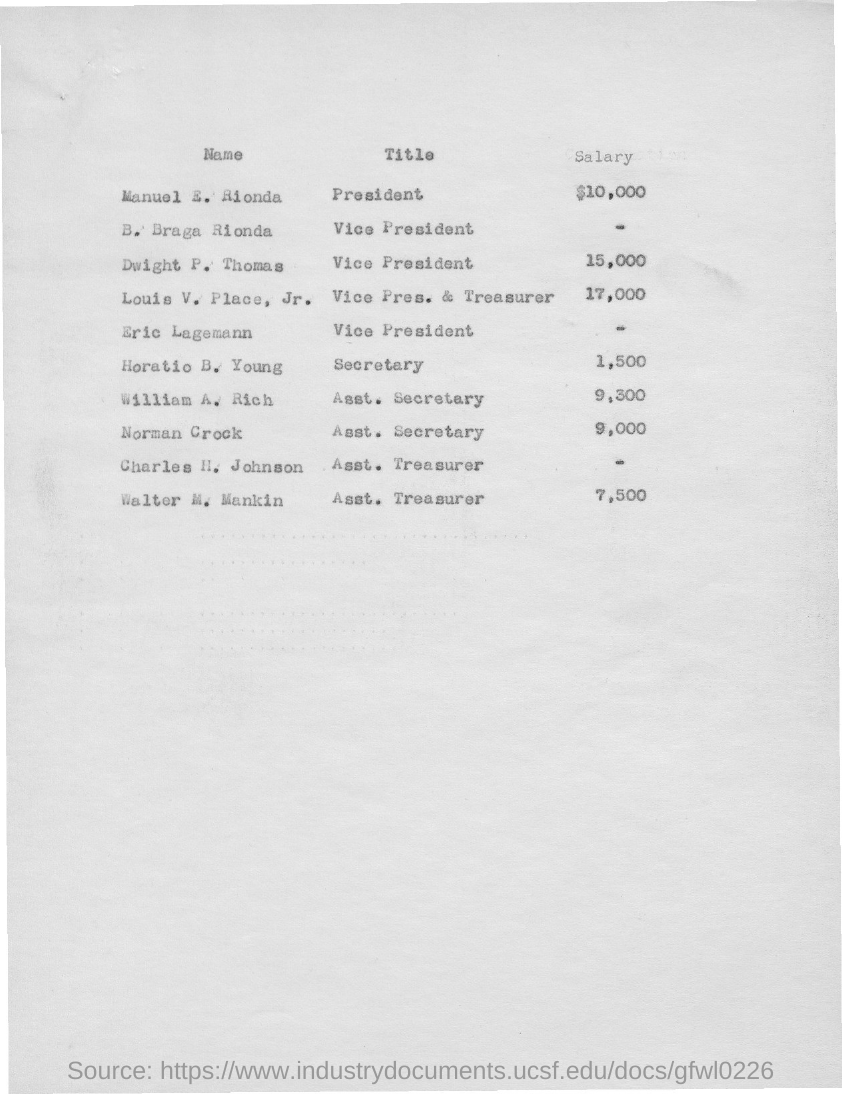What is the title given for manuel e. rionda as mentioned in the given page ?
Provide a short and direct response. President. What is the salary for manuel e. rionda as mentioned in the given page ?
Ensure brevity in your answer.  $10,000. What is the salary mentioned for louis v. place,jr. ?
Provide a succinct answer. 17,000. What is the title given for horatio b. young as mentioned in the given page ?
Provide a short and direct response. Secretary. What is the title given for norman crock  as mentioned in the given page ?
Offer a very short reply. Asst. secretary. What is the salary given for william a. rich as mentioned in the given page ?
Provide a short and direct response. 9,300. What is the title given for walter m. mankin as mentioned in the given page ?
Your answer should be very brief. Asst . Treasurer. What is the title given for eric lagemann as mentioned in the given page ?
Give a very brief answer. Vice president. What is the salary given for norman crock as mentioned in the given page ?
Your answer should be very brief. 9,000. What is the title given for charles h. johnson  as mentioned in the given page ?
Your response must be concise. Asst. treasurer. 